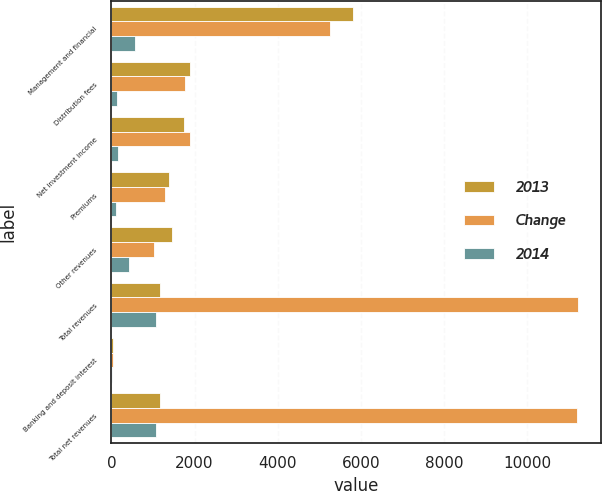Convert chart to OTSL. <chart><loc_0><loc_0><loc_500><loc_500><stacked_bar_chart><ecel><fcel>Management and financial<fcel>Distribution fees<fcel>Net investment income<fcel>Premiums<fcel>Other revenues<fcel>Total revenues<fcel>Banking and deposit interest<fcel>Total net revenues<nl><fcel>2013<fcel>5810<fcel>1894<fcel>1741<fcel>1385<fcel>1466<fcel>1175.5<fcel>28<fcel>1175.5<nl><fcel>Change<fcel>5253<fcel>1771<fcel>1889<fcel>1282<fcel>1035<fcel>11230<fcel>31<fcel>11199<nl><fcel>2014<fcel>557<fcel>123<fcel>148<fcel>103<fcel>431<fcel>1066<fcel>3<fcel>1069<nl></chart> 